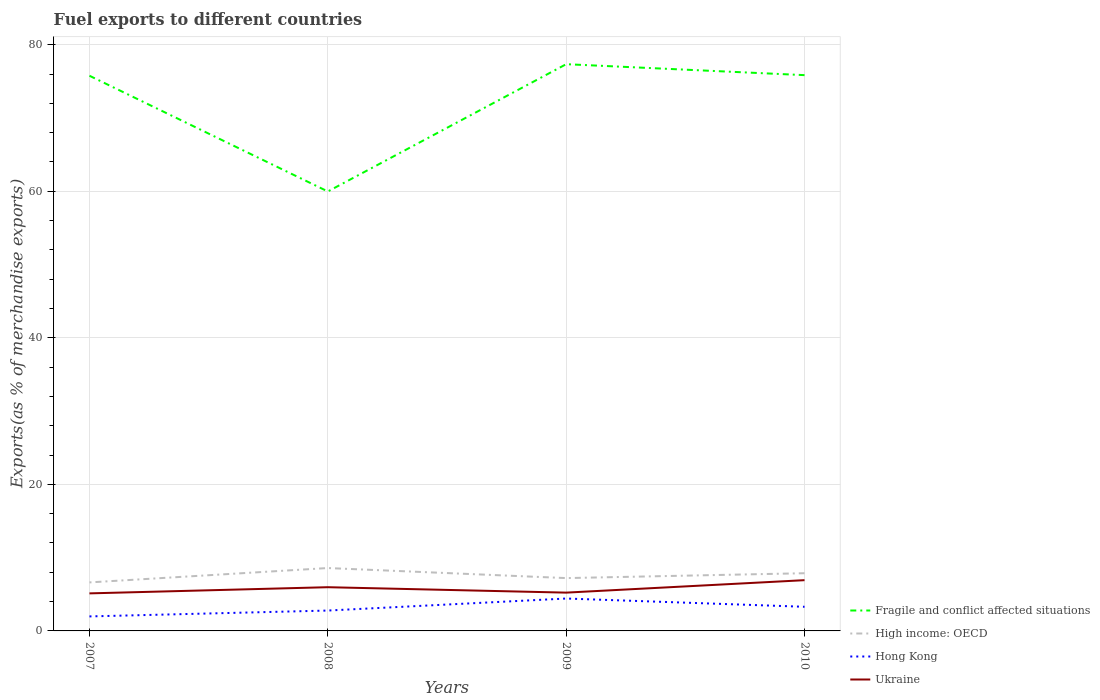Is the number of lines equal to the number of legend labels?
Your answer should be compact. Yes. Across all years, what is the maximum percentage of exports to different countries in Fragile and conflict affected situations?
Provide a succinct answer. 59.98. What is the total percentage of exports to different countries in Hong Kong in the graph?
Provide a succinct answer. -2.44. What is the difference between the highest and the second highest percentage of exports to different countries in High income: OECD?
Ensure brevity in your answer.  1.96. What is the difference between the highest and the lowest percentage of exports to different countries in High income: OECD?
Your response must be concise. 2. Is the percentage of exports to different countries in Ukraine strictly greater than the percentage of exports to different countries in Hong Kong over the years?
Your answer should be compact. No. What is the difference between two consecutive major ticks on the Y-axis?
Provide a succinct answer. 20. Does the graph contain any zero values?
Your response must be concise. No. Where does the legend appear in the graph?
Your answer should be very brief. Bottom right. How many legend labels are there?
Your response must be concise. 4. What is the title of the graph?
Provide a short and direct response. Fuel exports to different countries. What is the label or title of the X-axis?
Ensure brevity in your answer.  Years. What is the label or title of the Y-axis?
Your answer should be compact. Exports(as % of merchandise exports). What is the Exports(as % of merchandise exports) of Fragile and conflict affected situations in 2007?
Keep it short and to the point. 75.77. What is the Exports(as % of merchandise exports) in High income: OECD in 2007?
Your answer should be compact. 6.62. What is the Exports(as % of merchandise exports) of Hong Kong in 2007?
Provide a short and direct response. 1.98. What is the Exports(as % of merchandise exports) in Ukraine in 2007?
Provide a succinct answer. 5.12. What is the Exports(as % of merchandise exports) of Fragile and conflict affected situations in 2008?
Provide a short and direct response. 59.98. What is the Exports(as % of merchandise exports) of High income: OECD in 2008?
Keep it short and to the point. 8.58. What is the Exports(as % of merchandise exports) of Hong Kong in 2008?
Give a very brief answer. 2.78. What is the Exports(as % of merchandise exports) in Ukraine in 2008?
Keep it short and to the point. 5.97. What is the Exports(as % of merchandise exports) of Fragile and conflict affected situations in 2009?
Your response must be concise. 77.35. What is the Exports(as % of merchandise exports) of High income: OECD in 2009?
Provide a short and direct response. 7.21. What is the Exports(as % of merchandise exports) in Hong Kong in 2009?
Provide a short and direct response. 4.42. What is the Exports(as % of merchandise exports) in Ukraine in 2009?
Offer a terse response. 5.23. What is the Exports(as % of merchandise exports) of Fragile and conflict affected situations in 2010?
Provide a succinct answer. 75.85. What is the Exports(as % of merchandise exports) of High income: OECD in 2010?
Keep it short and to the point. 7.88. What is the Exports(as % of merchandise exports) in Hong Kong in 2010?
Offer a very short reply. 3.29. What is the Exports(as % of merchandise exports) of Ukraine in 2010?
Your answer should be compact. 6.93. Across all years, what is the maximum Exports(as % of merchandise exports) in Fragile and conflict affected situations?
Give a very brief answer. 77.35. Across all years, what is the maximum Exports(as % of merchandise exports) in High income: OECD?
Provide a short and direct response. 8.58. Across all years, what is the maximum Exports(as % of merchandise exports) in Hong Kong?
Offer a very short reply. 4.42. Across all years, what is the maximum Exports(as % of merchandise exports) of Ukraine?
Provide a short and direct response. 6.93. Across all years, what is the minimum Exports(as % of merchandise exports) in Fragile and conflict affected situations?
Provide a short and direct response. 59.98. Across all years, what is the minimum Exports(as % of merchandise exports) in High income: OECD?
Offer a terse response. 6.62. Across all years, what is the minimum Exports(as % of merchandise exports) of Hong Kong?
Provide a short and direct response. 1.98. Across all years, what is the minimum Exports(as % of merchandise exports) of Ukraine?
Offer a very short reply. 5.12. What is the total Exports(as % of merchandise exports) of Fragile and conflict affected situations in the graph?
Make the answer very short. 288.94. What is the total Exports(as % of merchandise exports) of High income: OECD in the graph?
Keep it short and to the point. 30.29. What is the total Exports(as % of merchandise exports) of Hong Kong in the graph?
Provide a succinct answer. 12.48. What is the total Exports(as % of merchandise exports) in Ukraine in the graph?
Ensure brevity in your answer.  23.24. What is the difference between the Exports(as % of merchandise exports) of Fragile and conflict affected situations in 2007 and that in 2008?
Ensure brevity in your answer.  15.8. What is the difference between the Exports(as % of merchandise exports) of High income: OECD in 2007 and that in 2008?
Offer a terse response. -1.96. What is the difference between the Exports(as % of merchandise exports) in Hong Kong in 2007 and that in 2008?
Your answer should be compact. -0.8. What is the difference between the Exports(as % of merchandise exports) in Ukraine in 2007 and that in 2008?
Offer a terse response. -0.84. What is the difference between the Exports(as % of merchandise exports) in Fragile and conflict affected situations in 2007 and that in 2009?
Make the answer very short. -1.58. What is the difference between the Exports(as % of merchandise exports) in High income: OECD in 2007 and that in 2009?
Offer a terse response. -0.59. What is the difference between the Exports(as % of merchandise exports) in Hong Kong in 2007 and that in 2009?
Offer a very short reply. -2.44. What is the difference between the Exports(as % of merchandise exports) of Ukraine in 2007 and that in 2009?
Your answer should be compact. -0.1. What is the difference between the Exports(as % of merchandise exports) in Fragile and conflict affected situations in 2007 and that in 2010?
Provide a succinct answer. -0.08. What is the difference between the Exports(as % of merchandise exports) in High income: OECD in 2007 and that in 2010?
Offer a very short reply. -1.25. What is the difference between the Exports(as % of merchandise exports) in Hong Kong in 2007 and that in 2010?
Offer a terse response. -1.31. What is the difference between the Exports(as % of merchandise exports) in Ukraine in 2007 and that in 2010?
Your answer should be very brief. -1.8. What is the difference between the Exports(as % of merchandise exports) in Fragile and conflict affected situations in 2008 and that in 2009?
Your response must be concise. -17.37. What is the difference between the Exports(as % of merchandise exports) in High income: OECD in 2008 and that in 2009?
Your answer should be compact. 1.37. What is the difference between the Exports(as % of merchandise exports) of Hong Kong in 2008 and that in 2009?
Your answer should be compact. -1.64. What is the difference between the Exports(as % of merchandise exports) of Ukraine in 2008 and that in 2009?
Offer a very short reply. 0.74. What is the difference between the Exports(as % of merchandise exports) of Fragile and conflict affected situations in 2008 and that in 2010?
Give a very brief answer. -15.88. What is the difference between the Exports(as % of merchandise exports) in High income: OECD in 2008 and that in 2010?
Offer a terse response. 0.71. What is the difference between the Exports(as % of merchandise exports) of Hong Kong in 2008 and that in 2010?
Your response must be concise. -0.51. What is the difference between the Exports(as % of merchandise exports) in Ukraine in 2008 and that in 2010?
Your answer should be very brief. -0.96. What is the difference between the Exports(as % of merchandise exports) in Fragile and conflict affected situations in 2009 and that in 2010?
Make the answer very short. 1.5. What is the difference between the Exports(as % of merchandise exports) in High income: OECD in 2009 and that in 2010?
Make the answer very short. -0.67. What is the difference between the Exports(as % of merchandise exports) of Hong Kong in 2009 and that in 2010?
Give a very brief answer. 1.13. What is the difference between the Exports(as % of merchandise exports) in Ukraine in 2009 and that in 2010?
Make the answer very short. -1.7. What is the difference between the Exports(as % of merchandise exports) of Fragile and conflict affected situations in 2007 and the Exports(as % of merchandise exports) of High income: OECD in 2008?
Make the answer very short. 67.19. What is the difference between the Exports(as % of merchandise exports) of Fragile and conflict affected situations in 2007 and the Exports(as % of merchandise exports) of Hong Kong in 2008?
Provide a short and direct response. 72.99. What is the difference between the Exports(as % of merchandise exports) in Fragile and conflict affected situations in 2007 and the Exports(as % of merchandise exports) in Ukraine in 2008?
Give a very brief answer. 69.8. What is the difference between the Exports(as % of merchandise exports) of High income: OECD in 2007 and the Exports(as % of merchandise exports) of Hong Kong in 2008?
Ensure brevity in your answer.  3.84. What is the difference between the Exports(as % of merchandise exports) of High income: OECD in 2007 and the Exports(as % of merchandise exports) of Ukraine in 2008?
Offer a very short reply. 0.65. What is the difference between the Exports(as % of merchandise exports) in Hong Kong in 2007 and the Exports(as % of merchandise exports) in Ukraine in 2008?
Your answer should be very brief. -3.99. What is the difference between the Exports(as % of merchandise exports) of Fragile and conflict affected situations in 2007 and the Exports(as % of merchandise exports) of High income: OECD in 2009?
Keep it short and to the point. 68.56. What is the difference between the Exports(as % of merchandise exports) in Fragile and conflict affected situations in 2007 and the Exports(as % of merchandise exports) in Hong Kong in 2009?
Give a very brief answer. 71.35. What is the difference between the Exports(as % of merchandise exports) of Fragile and conflict affected situations in 2007 and the Exports(as % of merchandise exports) of Ukraine in 2009?
Your answer should be compact. 70.54. What is the difference between the Exports(as % of merchandise exports) in High income: OECD in 2007 and the Exports(as % of merchandise exports) in Hong Kong in 2009?
Your answer should be compact. 2.2. What is the difference between the Exports(as % of merchandise exports) in High income: OECD in 2007 and the Exports(as % of merchandise exports) in Ukraine in 2009?
Your response must be concise. 1.4. What is the difference between the Exports(as % of merchandise exports) in Hong Kong in 2007 and the Exports(as % of merchandise exports) in Ukraine in 2009?
Provide a succinct answer. -3.25. What is the difference between the Exports(as % of merchandise exports) of Fragile and conflict affected situations in 2007 and the Exports(as % of merchandise exports) of High income: OECD in 2010?
Provide a short and direct response. 67.9. What is the difference between the Exports(as % of merchandise exports) of Fragile and conflict affected situations in 2007 and the Exports(as % of merchandise exports) of Hong Kong in 2010?
Keep it short and to the point. 72.48. What is the difference between the Exports(as % of merchandise exports) in Fragile and conflict affected situations in 2007 and the Exports(as % of merchandise exports) in Ukraine in 2010?
Your answer should be very brief. 68.84. What is the difference between the Exports(as % of merchandise exports) in High income: OECD in 2007 and the Exports(as % of merchandise exports) in Hong Kong in 2010?
Give a very brief answer. 3.33. What is the difference between the Exports(as % of merchandise exports) of High income: OECD in 2007 and the Exports(as % of merchandise exports) of Ukraine in 2010?
Make the answer very short. -0.3. What is the difference between the Exports(as % of merchandise exports) of Hong Kong in 2007 and the Exports(as % of merchandise exports) of Ukraine in 2010?
Give a very brief answer. -4.95. What is the difference between the Exports(as % of merchandise exports) of Fragile and conflict affected situations in 2008 and the Exports(as % of merchandise exports) of High income: OECD in 2009?
Offer a terse response. 52.77. What is the difference between the Exports(as % of merchandise exports) in Fragile and conflict affected situations in 2008 and the Exports(as % of merchandise exports) in Hong Kong in 2009?
Give a very brief answer. 55.55. What is the difference between the Exports(as % of merchandise exports) of Fragile and conflict affected situations in 2008 and the Exports(as % of merchandise exports) of Ukraine in 2009?
Make the answer very short. 54.75. What is the difference between the Exports(as % of merchandise exports) of High income: OECD in 2008 and the Exports(as % of merchandise exports) of Hong Kong in 2009?
Give a very brief answer. 4.16. What is the difference between the Exports(as % of merchandise exports) of High income: OECD in 2008 and the Exports(as % of merchandise exports) of Ukraine in 2009?
Your answer should be very brief. 3.36. What is the difference between the Exports(as % of merchandise exports) in Hong Kong in 2008 and the Exports(as % of merchandise exports) in Ukraine in 2009?
Your answer should be very brief. -2.44. What is the difference between the Exports(as % of merchandise exports) in Fragile and conflict affected situations in 2008 and the Exports(as % of merchandise exports) in High income: OECD in 2010?
Offer a very short reply. 52.1. What is the difference between the Exports(as % of merchandise exports) of Fragile and conflict affected situations in 2008 and the Exports(as % of merchandise exports) of Hong Kong in 2010?
Keep it short and to the point. 56.68. What is the difference between the Exports(as % of merchandise exports) of Fragile and conflict affected situations in 2008 and the Exports(as % of merchandise exports) of Ukraine in 2010?
Offer a terse response. 53.05. What is the difference between the Exports(as % of merchandise exports) in High income: OECD in 2008 and the Exports(as % of merchandise exports) in Hong Kong in 2010?
Provide a short and direct response. 5.29. What is the difference between the Exports(as % of merchandise exports) in High income: OECD in 2008 and the Exports(as % of merchandise exports) in Ukraine in 2010?
Offer a terse response. 1.66. What is the difference between the Exports(as % of merchandise exports) in Hong Kong in 2008 and the Exports(as % of merchandise exports) in Ukraine in 2010?
Ensure brevity in your answer.  -4.14. What is the difference between the Exports(as % of merchandise exports) in Fragile and conflict affected situations in 2009 and the Exports(as % of merchandise exports) in High income: OECD in 2010?
Give a very brief answer. 69.47. What is the difference between the Exports(as % of merchandise exports) of Fragile and conflict affected situations in 2009 and the Exports(as % of merchandise exports) of Hong Kong in 2010?
Your answer should be very brief. 74.05. What is the difference between the Exports(as % of merchandise exports) in Fragile and conflict affected situations in 2009 and the Exports(as % of merchandise exports) in Ukraine in 2010?
Provide a succinct answer. 70.42. What is the difference between the Exports(as % of merchandise exports) of High income: OECD in 2009 and the Exports(as % of merchandise exports) of Hong Kong in 2010?
Provide a succinct answer. 3.92. What is the difference between the Exports(as % of merchandise exports) of High income: OECD in 2009 and the Exports(as % of merchandise exports) of Ukraine in 2010?
Keep it short and to the point. 0.28. What is the difference between the Exports(as % of merchandise exports) in Hong Kong in 2009 and the Exports(as % of merchandise exports) in Ukraine in 2010?
Make the answer very short. -2.5. What is the average Exports(as % of merchandise exports) in Fragile and conflict affected situations per year?
Your response must be concise. 72.24. What is the average Exports(as % of merchandise exports) in High income: OECD per year?
Your answer should be very brief. 7.57. What is the average Exports(as % of merchandise exports) in Hong Kong per year?
Ensure brevity in your answer.  3.12. What is the average Exports(as % of merchandise exports) in Ukraine per year?
Keep it short and to the point. 5.81. In the year 2007, what is the difference between the Exports(as % of merchandise exports) in Fragile and conflict affected situations and Exports(as % of merchandise exports) in High income: OECD?
Give a very brief answer. 69.15. In the year 2007, what is the difference between the Exports(as % of merchandise exports) of Fragile and conflict affected situations and Exports(as % of merchandise exports) of Hong Kong?
Provide a short and direct response. 73.79. In the year 2007, what is the difference between the Exports(as % of merchandise exports) of Fragile and conflict affected situations and Exports(as % of merchandise exports) of Ukraine?
Your answer should be compact. 70.65. In the year 2007, what is the difference between the Exports(as % of merchandise exports) in High income: OECD and Exports(as % of merchandise exports) in Hong Kong?
Provide a short and direct response. 4.64. In the year 2007, what is the difference between the Exports(as % of merchandise exports) in High income: OECD and Exports(as % of merchandise exports) in Ukraine?
Provide a short and direct response. 1.5. In the year 2007, what is the difference between the Exports(as % of merchandise exports) of Hong Kong and Exports(as % of merchandise exports) of Ukraine?
Your answer should be compact. -3.14. In the year 2008, what is the difference between the Exports(as % of merchandise exports) in Fragile and conflict affected situations and Exports(as % of merchandise exports) in High income: OECD?
Your response must be concise. 51.39. In the year 2008, what is the difference between the Exports(as % of merchandise exports) of Fragile and conflict affected situations and Exports(as % of merchandise exports) of Hong Kong?
Provide a short and direct response. 57.19. In the year 2008, what is the difference between the Exports(as % of merchandise exports) in Fragile and conflict affected situations and Exports(as % of merchandise exports) in Ukraine?
Keep it short and to the point. 54.01. In the year 2008, what is the difference between the Exports(as % of merchandise exports) in High income: OECD and Exports(as % of merchandise exports) in Hong Kong?
Give a very brief answer. 5.8. In the year 2008, what is the difference between the Exports(as % of merchandise exports) of High income: OECD and Exports(as % of merchandise exports) of Ukraine?
Your answer should be very brief. 2.62. In the year 2008, what is the difference between the Exports(as % of merchandise exports) in Hong Kong and Exports(as % of merchandise exports) in Ukraine?
Give a very brief answer. -3.19. In the year 2009, what is the difference between the Exports(as % of merchandise exports) of Fragile and conflict affected situations and Exports(as % of merchandise exports) of High income: OECD?
Offer a terse response. 70.14. In the year 2009, what is the difference between the Exports(as % of merchandise exports) of Fragile and conflict affected situations and Exports(as % of merchandise exports) of Hong Kong?
Provide a short and direct response. 72.93. In the year 2009, what is the difference between the Exports(as % of merchandise exports) of Fragile and conflict affected situations and Exports(as % of merchandise exports) of Ukraine?
Provide a short and direct response. 72.12. In the year 2009, what is the difference between the Exports(as % of merchandise exports) of High income: OECD and Exports(as % of merchandise exports) of Hong Kong?
Provide a short and direct response. 2.79. In the year 2009, what is the difference between the Exports(as % of merchandise exports) in High income: OECD and Exports(as % of merchandise exports) in Ukraine?
Provide a short and direct response. 1.98. In the year 2009, what is the difference between the Exports(as % of merchandise exports) in Hong Kong and Exports(as % of merchandise exports) in Ukraine?
Provide a short and direct response. -0.8. In the year 2010, what is the difference between the Exports(as % of merchandise exports) in Fragile and conflict affected situations and Exports(as % of merchandise exports) in High income: OECD?
Make the answer very short. 67.98. In the year 2010, what is the difference between the Exports(as % of merchandise exports) of Fragile and conflict affected situations and Exports(as % of merchandise exports) of Hong Kong?
Keep it short and to the point. 72.56. In the year 2010, what is the difference between the Exports(as % of merchandise exports) of Fragile and conflict affected situations and Exports(as % of merchandise exports) of Ukraine?
Offer a terse response. 68.93. In the year 2010, what is the difference between the Exports(as % of merchandise exports) in High income: OECD and Exports(as % of merchandise exports) in Hong Kong?
Give a very brief answer. 4.58. In the year 2010, what is the difference between the Exports(as % of merchandise exports) in High income: OECD and Exports(as % of merchandise exports) in Ukraine?
Provide a short and direct response. 0.95. In the year 2010, what is the difference between the Exports(as % of merchandise exports) of Hong Kong and Exports(as % of merchandise exports) of Ukraine?
Ensure brevity in your answer.  -3.63. What is the ratio of the Exports(as % of merchandise exports) of Fragile and conflict affected situations in 2007 to that in 2008?
Your answer should be very brief. 1.26. What is the ratio of the Exports(as % of merchandise exports) of High income: OECD in 2007 to that in 2008?
Give a very brief answer. 0.77. What is the ratio of the Exports(as % of merchandise exports) in Hong Kong in 2007 to that in 2008?
Make the answer very short. 0.71. What is the ratio of the Exports(as % of merchandise exports) of Ukraine in 2007 to that in 2008?
Offer a terse response. 0.86. What is the ratio of the Exports(as % of merchandise exports) in Fragile and conflict affected situations in 2007 to that in 2009?
Give a very brief answer. 0.98. What is the ratio of the Exports(as % of merchandise exports) in High income: OECD in 2007 to that in 2009?
Your answer should be compact. 0.92. What is the ratio of the Exports(as % of merchandise exports) in Hong Kong in 2007 to that in 2009?
Keep it short and to the point. 0.45. What is the ratio of the Exports(as % of merchandise exports) in Ukraine in 2007 to that in 2009?
Provide a short and direct response. 0.98. What is the ratio of the Exports(as % of merchandise exports) in High income: OECD in 2007 to that in 2010?
Make the answer very short. 0.84. What is the ratio of the Exports(as % of merchandise exports) in Hong Kong in 2007 to that in 2010?
Make the answer very short. 0.6. What is the ratio of the Exports(as % of merchandise exports) in Ukraine in 2007 to that in 2010?
Provide a short and direct response. 0.74. What is the ratio of the Exports(as % of merchandise exports) of Fragile and conflict affected situations in 2008 to that in 2009?
Offer a very short reply. 0.78. What is the ratio of the Exports(as % of merchandise exports) of High income: OECD in 2008 to that in 2009?
Give a very brief answer. 1.19. What is the ratio of the Exports(as % of merchandise exports) of Hong Kong in 2008 to that in 2009?
Make the answer very short. 0.63. What is the ratio of the Exports(as % of merchandise exports) of Ukraine in 2008 to that in 2009?
Provide a short and direct response. 1.14. What is the ratio of the Exports(as % of merchandise exports) in Fragile and conflict affected situations in 2008 to that in 2010?
Keep it short and to the point. 0.79. What is the ratio of the Exports(as % of merchandise exports) of High income: OECD in 2008 to that in 2010?
Offer a terse response. 1.09. What is the ratio of the Exports(as % of merchandise exports) of Hong Kong in 2008 to that in 2010?
Your answer should be very brief. 0.84. What is the ratio of the Exports(as % of merchandise exports) of Ukraine in 2008 to that in 2010?
Offer a terse response. 0.86. What is the ratio of the Exports(as % of merchandise exports) of Fragile and conflict affected situations in 2009 to that in 2010?
Offer a very short reply. 1.02. What is the ratio of the Exports(as % of merchandise exports) in High income: OECD in 2009 to that in 2010?
Your answer should be very brief. 0.92. What is the ratio of the Exports(as % of merchandise exports) in Hong Kong in 2009 to that in 2010?
Make the answer very short. 1.34. What is the ratio of the Exports(as % of merchandise exports) of Ukraine in 2009 to that in 2010?
Your answer should be compact. 0.75. What is the difference between the highest and the second highest Exports(as % of merchandise exports) of Fragile and conflict affected situations?
Your response must be concise. 1.5. What is the difference between the highest and the second highest Exports(as % of merchandise exports) in High income: OECD?
Ensure brevity in your answer.  0.71. What is the difference between the highest and the second highest Exports(as % of merchandise exports) in Hong Kong?
Give a very brief answer. 1.13. What is the difference between the highest and the second highest Exports(as % of merchandise exports) of Ukraine?
Make the answer very short. 0.96. What is the difference between the highest and the lowest Exports(as % of merchandise exports) of Fragile and conflict affected situations?
Provide a succinct answer. 17.37. What is the difference between the highest and the lowest Exports(as % of merchandise exports) in High income: OECD?
Make the answer very short. 1.96. What is the difference between the highest and the lowest Exports(as % of merchandise exports) in Hong Kong?
Your answer should be compact. 2.44. What is the difference between the highest and the lowest Exports(as % of merchandise exports) of Ukraine?
Offer a terse response. 1.8. 